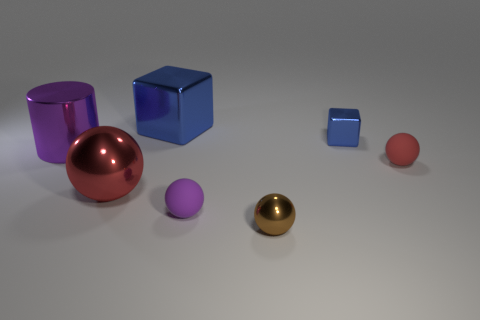Subtract all green balls. Subtract all purple cubes. How many balls are left? 4 Subtract all spheres. How many objects are left? 3 Add 1 small shiny blocks. How many objects exist? 8 Subtract all big cylinders. Subtract all shiny cubes. How many objects are left? 4 Add 1 tiny shiny objects. How many tiny shiny objects are left? 3 Add 4 small blue metallic things. How many small blue metallic things exist? 5 Subtract 0 green spheres. How many objects are left? 7 